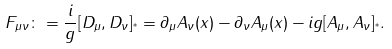Convert formula to latex. <formula><loc_0><loc_0><loc_500><loc_500>F _ { \mu \nu } \colon = \frac { i } { g } [ D _ { \mu } , D _ { \nu } ] _ { ^ { * } } = \partial _ { \mu } A _ { \nu } ( x ) - \partial _ { \nu } A _ { \mu } ( x ) - i g [ A _ { \mu } , A _ { \nu } ] _ { ^ { * } } .</formula> 